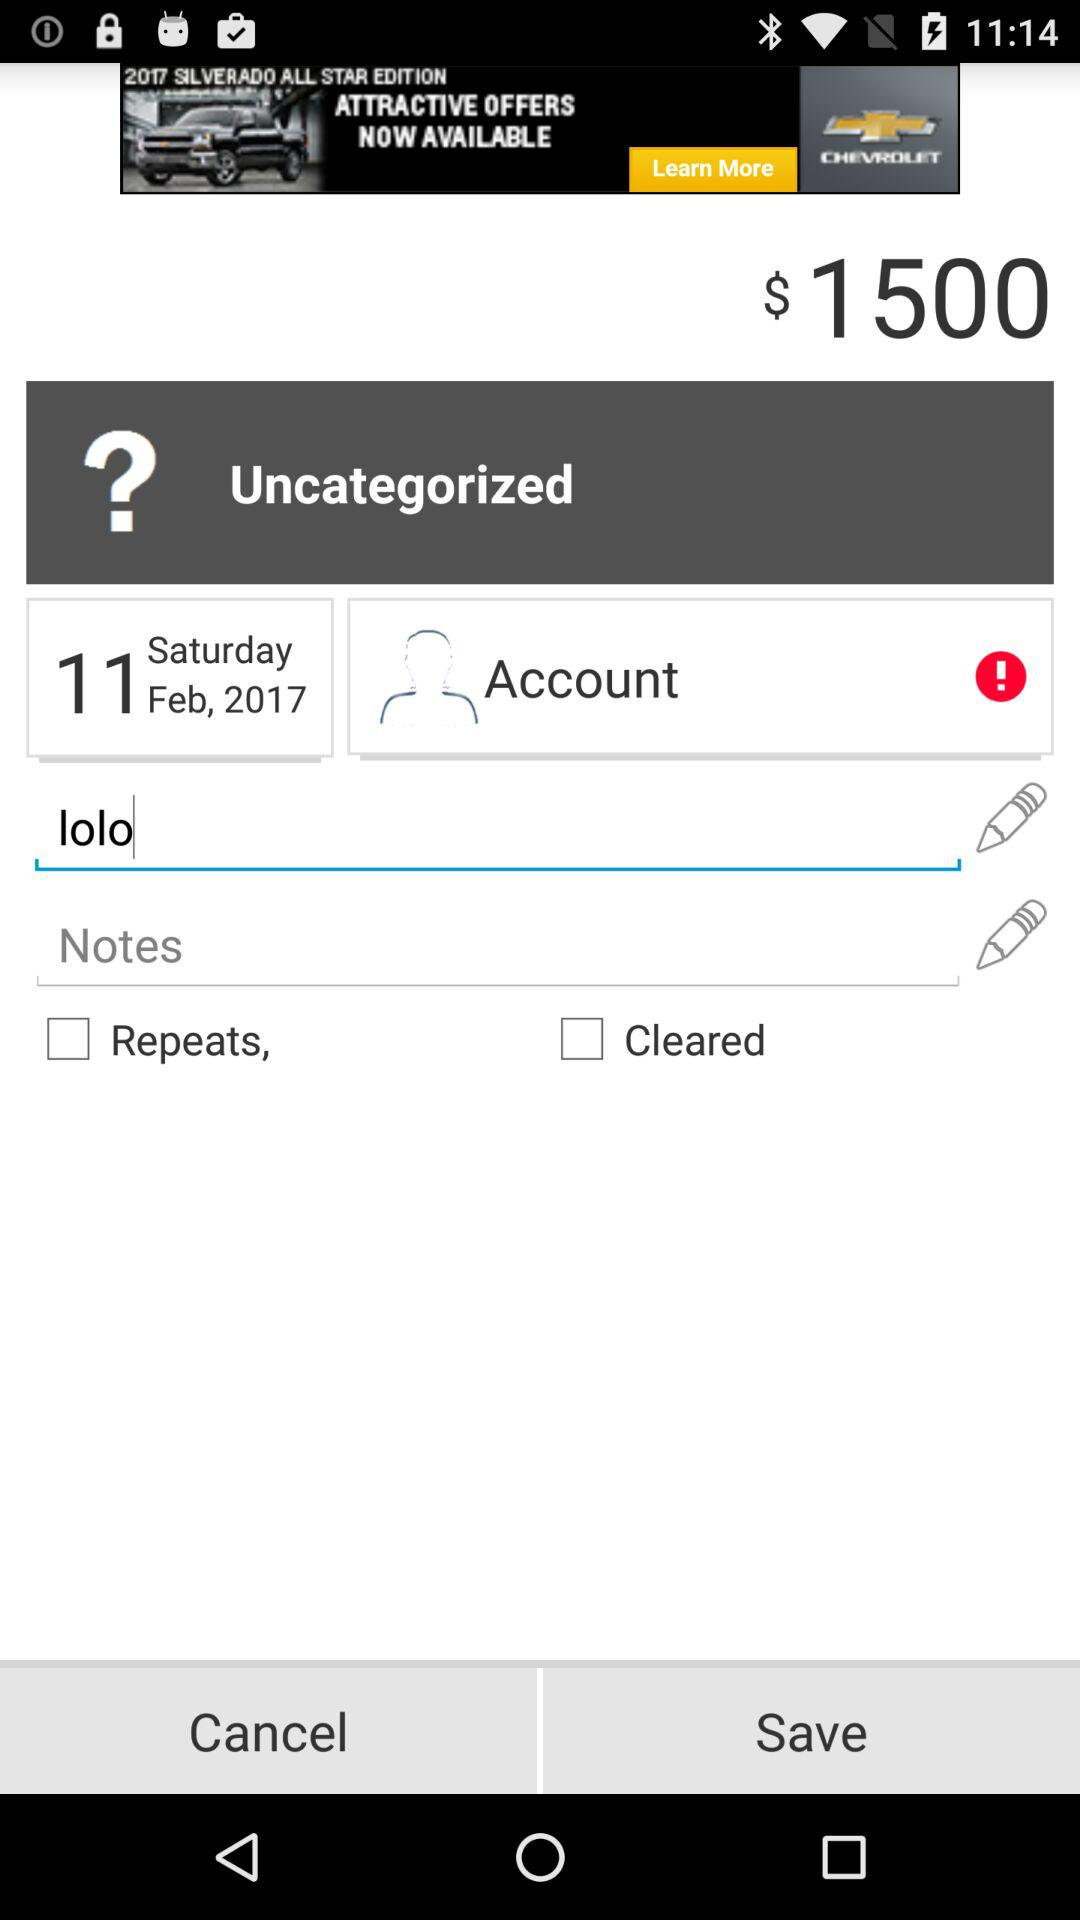Was the account saved?
When the provided information is insufficient, respond with <no answer>. <no answer> 